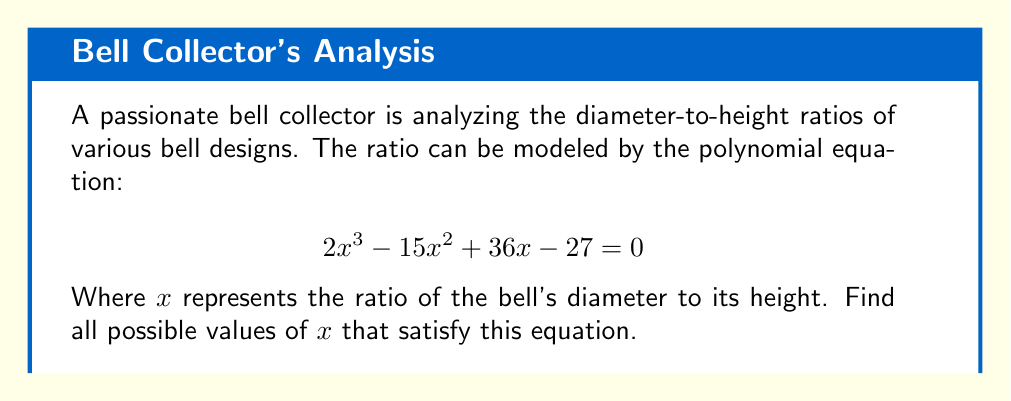Give your solution to this math problem. To solve this polynomial equation, we'll follow these steps:

1) First, we can factor out the greatest common factor (GCF):
   $$2x^3 - 15x^2 + 36x - 27 = 0$$
   There is no common factor, so we proceed to the next step.

2) Check if this is a perfect cube polynomial:
   It's not a perfect cube, so we move on.

3) Try to factor by grouping:
   $$(2x^3 - 15x^2) + (36x - 27) = 0$$
   $$(2x^2(x - \frac{15}{2})) + (9(4x - 3)) = 0$$
   $$x^2(2x - 15) + 9(4x - 3) = 0$$

4) Factor out $(2x - 3)$:
   $$(2x - 3)(x^2 + 3x - 9) = 0$$

5) Use the quadratic formula to solve $x^2 + 3x - 9 = 0$:
   $$x = \frac{-3 \pm \sqrt{3^2 - 4(1)(-9)}}{2(1)}$$
   $$x = \frac{-3 \pm \sqrt{45}}{2}$$
   $$x = \frac{-3 \pm 3\sqrt{5}}{2}$$

6) Solve $2x - 3 = 0$:
   $$x = \frac{3}{2}$$

Therefore, the three solutions are:

$$x_1 = \frac{3}{2}$$
$$x_2 = \frac{-3 + 3\sqrt{5}}{2}$$
$$x_3 = \frac{-3 - 3\sqrt{5}}{2}$$
Answer: $x = \frac{3}{2}, \frac{-3 + 3\sqrt{5}}{2}, \frac{-3 - 3\sqrt{5}}{2}$ 